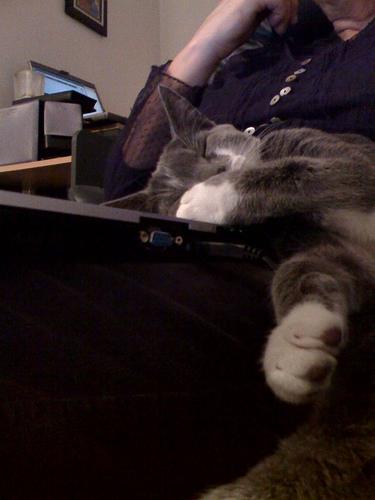What color is the cat?
Write a very short answer. Gray. What brand laptop is this?
Be succinct. Dell. What brand is the monitor in the back of the cat?
Concise answer only. Dell. What color are the walls?
Keep it brief. White. Is there a remote next to the cat?
Answer briefly. No. Where is the cat looking?
Give a very brief answer. Sleeping. What type of cat is this?
Keep it brief. Gray. What is the cat's head resting on?
Quick response, please. Laptop. What is the cat watching on the TV?
Be succinct. Nothing. Is the cat watching television?
Give a very brief answer. No. What type of animal is this?
Quick response, please. Cat. 